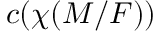Convert formula to latex. <formula><loc_0><loc_0><loc_500><loc_500>c ( \chi ( M / F ) )</formula> 